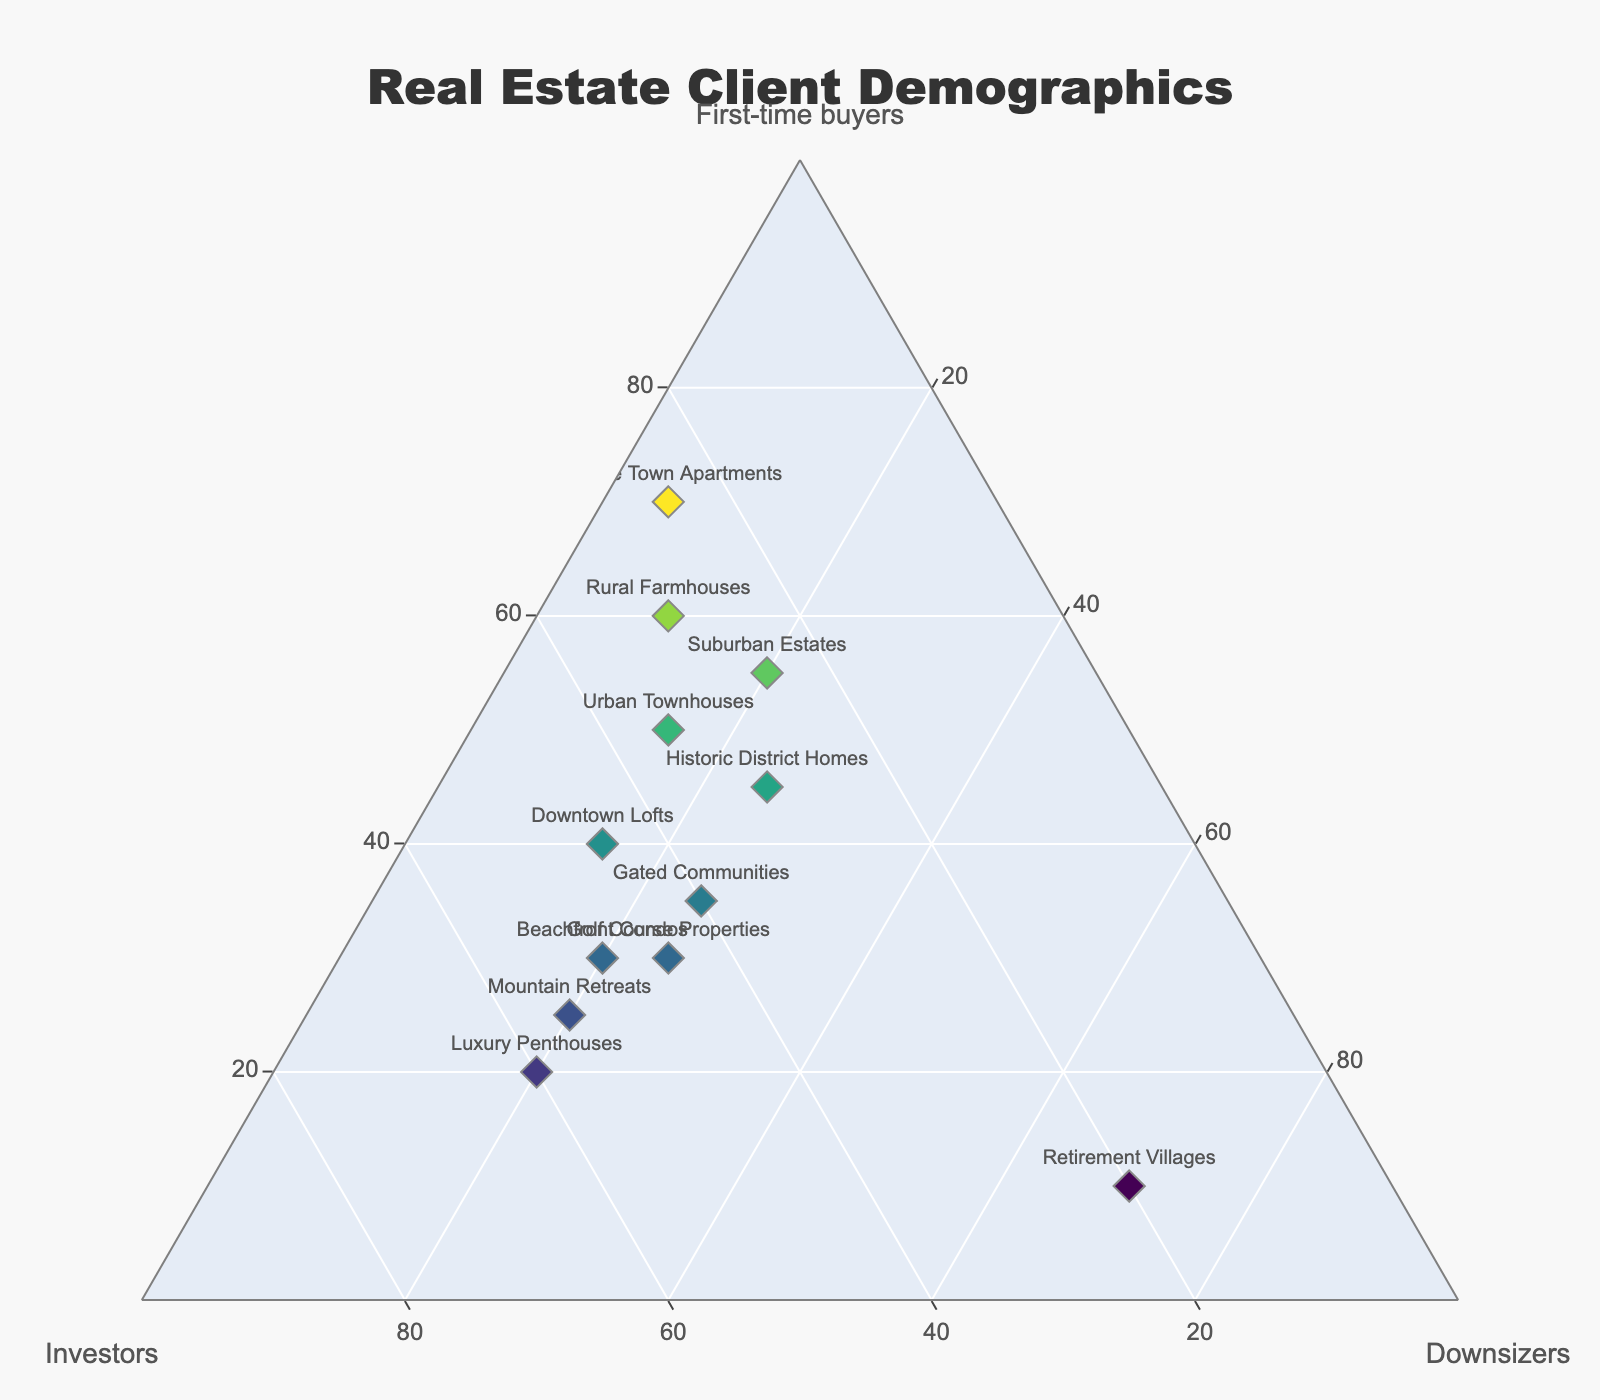What is the title of the plot? The title text is found at the top center of the plot and typically describes what the plot is about. In this case, the title is specified in the layout updates.
Answer: Real Estate Client Demographics What are the names of the three axes? The three axes are labeled in the plot. This can be seen from the ternary plot layout configurations.
Answer: First-time buyers, Investors, Downsizers How many locations have more First-time buyers than Downsizers? Check each point on the plot to see which ones have a higher value for First-time buyers than Downsizers.
Answer: 9 Which location has the highest percentage of Investors? Look for the point on the plot with the highest value for the Investors axis.
Answer: Luxury Penthouses What's the combined percentage of First-time buyers and Downsizers for Downtown Lofts? Add the percentage of First-time buyers to the percentage of Downsizers for Downtown Lofts. Downtown Lofts has 40% First-time buyers and 15% Downsizers.
Answer: 55% What is the average percentage of Investors across all locations? Sum the percentages of Investors for all locations and divide by the number of locations. The data provides the counts which can be summed up and averaged. (45 + 25 + 50 + 30 + 35 + 20 + 25 + 60 + 40 + 30 + 55 + 45)/12
Answer: 37.5% Which locations have an equal percentage of First-time buyers and Investors? Identify points on the plot where the values for First-time buyers and Investors are the same.
Answer: None Are there more locations with a higher percentage of Downsizers than Investors, or a higher percentage of Investors than Downsizers? Count the number of locations where Downsizers > Investors and compare it to the count where Investors > Downsizers. Downsizers > Investors: 1 (Retirement Villages), Investors > Downsizers: 11 (all others).
Answer: More locations have a higher percentage of Investors than Downsizers What is the sum of percentages for all three demographics (First-time buyers, Investors, Downsizers) for Beachfront Condos? Since the sum of the parts of a ternary plot equals 100%, the sum will also be 100%.
Answer: 100 